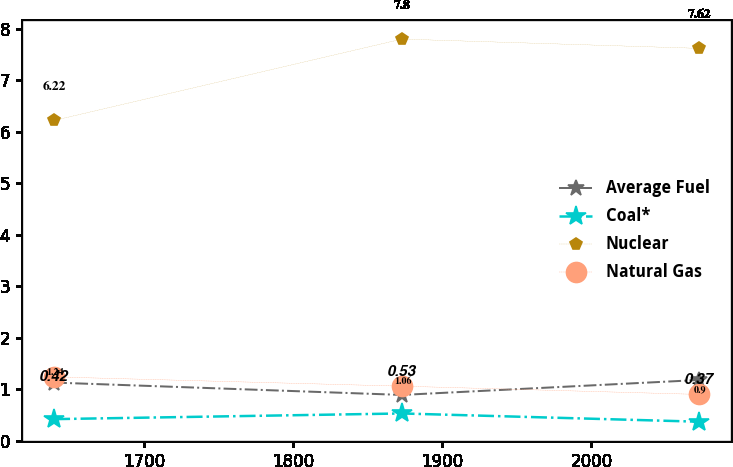Convert chart to OTSL. <chart><loc_0><loc_0><loc_500><loc_500><line_chart><ecel><fcel>Average Fuel<fcel>Coal*<fcel>Nuclear<fcel>Natural Gas<nl><fcel>1639.55<fcel>1.13<fcel>0.42<fcel>6.22<fcel>1.24<nl><fcel>1872.87<fcel>0.89<fcel>0.53<fcel>7.8<fcel>1.06<nl><fcel>2072.09<fcel>1.18<fcel>0.37<fcel>7.62<fcel>0.9<nl></chart> 